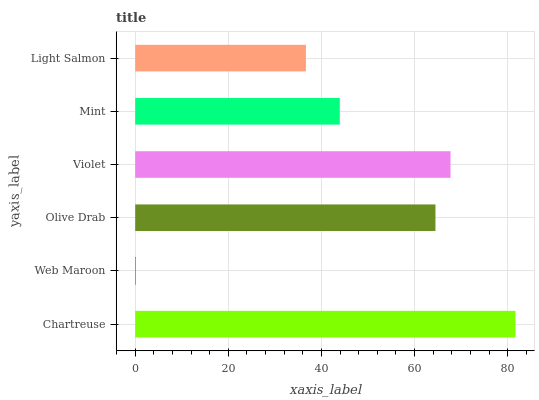Is Web Maroon the minimum?
Answer yes or no. Yes. Is Chartreuse the maximum?
Answer yes or no. Yes. Is Olive Drab the minimum?
Answer yes or no. No. Is Olive Drab the maximum?
Answer yes or no. No. Is Olive Drab greater than Web Maroon?
Answer yes or no. Yes. Is Web Maroon less than Olive Drab?
Answer yes or no. Yes. Is Web Maroon greater than Olive Drab?
Answer yes or no. No. Is Olive Drab less than Web Maroon?
Answer yes or no. No. Is Olive Drab the high median?
Answer yes or no. Yes. Is Mint the low median?
Answer yes or no. Yes. Is Mint the high median?
Answer yes or no. No. Is Violet the low median?
Answer yes or no. No. 